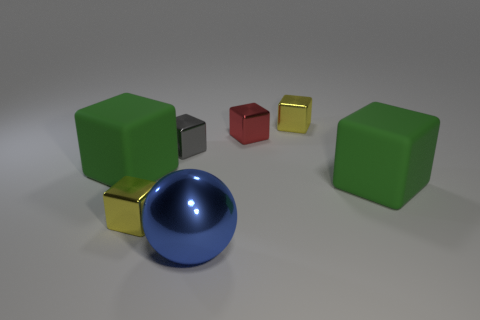Is there anything else of the same color as the large metal thing?
Your answer should be compact. No. Do the yellow block that is behind the small red cube and the large sphere have the same material?
Provide a succinct answer. Yes. What number of metal things are behind the blue object and on the left side of the red metallic object?
Your response must be concise. 2. There is a green matte thing that is on the right side of the yellow shiny block on the right side of the blue object; what is its size?
Make the answer very short. Large. Are there more objects than big cyan things?
Offer a terse response. Yes. There is a object that is behind the small red metal cube; does it have the same color as the large rubber cube that is to the left of the gray shiny block?
Your answer should be compact. No. Is there a red metal thing that is in front of the rubber object left of the large ball?
Provide a short and direct response. No. Are there fewer gray objects left of the small gray shiny object than small things that are on the right side of the red metallic object?
Your answer should be very brief. Yes. Is the material of the tiny yellow cube behind the gray metal thing the same as the small yellow cube on the left side of the tiny red metallic thing?
Keep it short and to the point. Yes. How many big things are yellow blocks or spheres?
Provide a short and direct response. 1. 